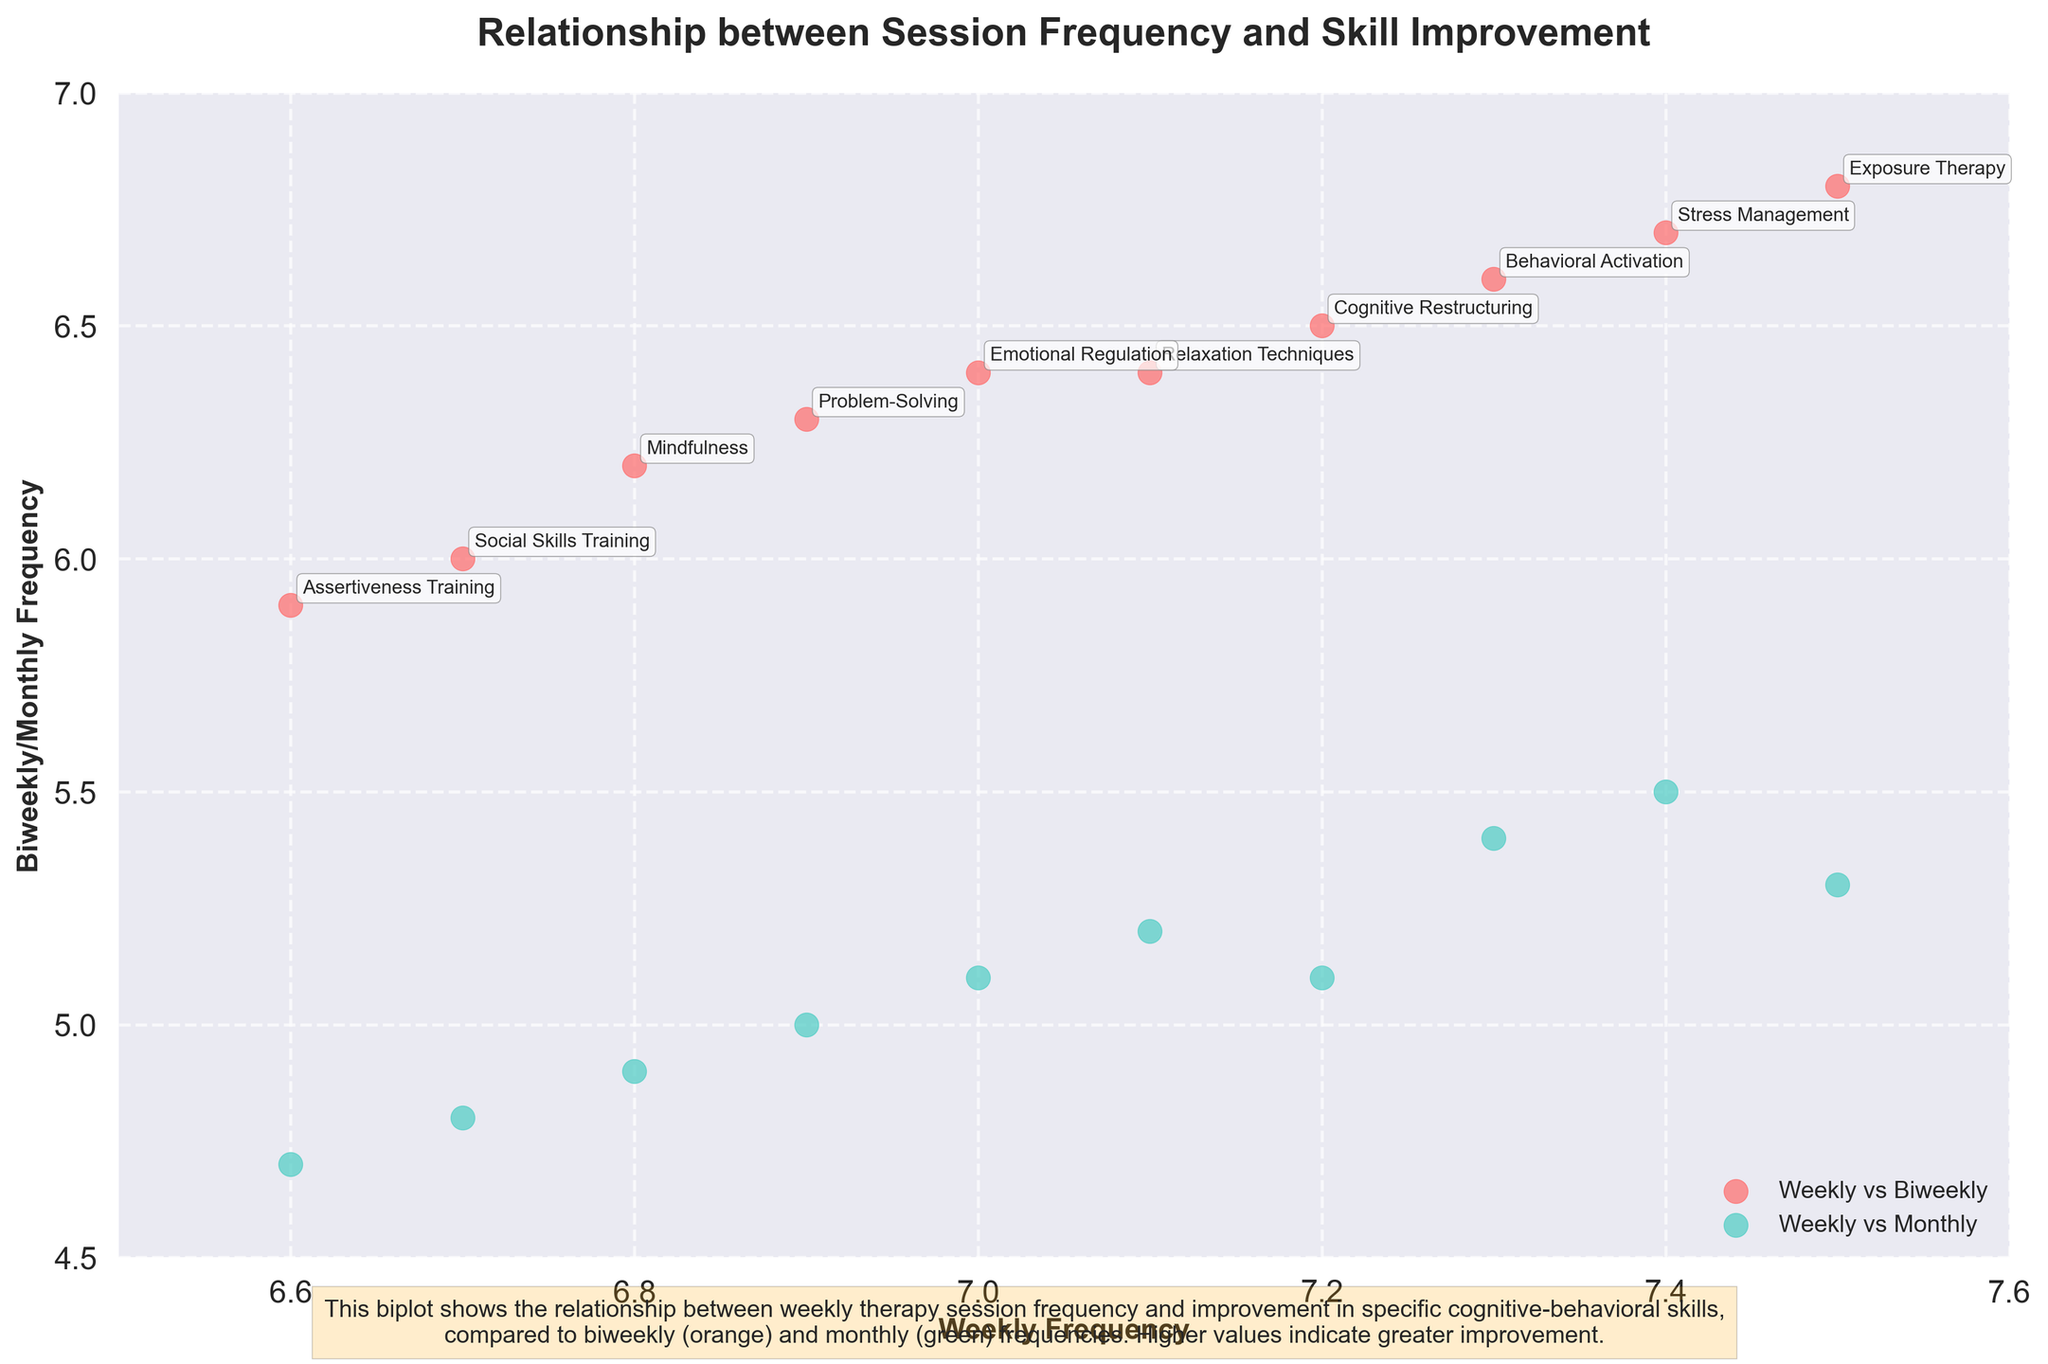What does the title of the plot indicate? The title "Relationship between Session Frequency and Skill Improvement" suggests that the plot examines how the frequency of therapy sessions relates to the improvement in specific cognitive-behavioral skills.
Answer: It indicates the relationship between session frequency and skill improvement How many skills are represented in the plot? Each annotated point in the plot represents a distinct skill, and there are 10 such annotations.
Answer: 10 skills What are the x and y axes labeled? The x-axis is labeled "Weekly Frequency," and the y-axis is labeled "Biweekly/Monthly Frequency."
Answer: "Weekly Frequency" and "Biweekly/Monthly Frequency" Which skills show the greatest improvement for weekly vs. biweekly frequencies? By identifying the points with the highest y-axis values in the "Weekly vs. Biweekly" scatter plot (red points), we see that "Exposure Therapy" and "Stress Management" have the greatest improvements.
Answer: "Exposure Therapy" and "Stress Management" How does the improvement in "Mindfulness" compare between weekly and monthly sessions? The point annotated with "Mindfulness" has a y-axis (monthly frequency) value of approximately 4.9 and an x-axis (weekly frequency) value of around 6.8, indicating that weekly sessions result in noticeably greater improvement.
Answer: Weekly sessions show greater improvement than monthly sessions Which frequency generally shows higher improvement: weekly or biweekly? Observing the general trend of the scatter plots, the red points (weekly vs. biweekly) are consistently positioned higher along the y-axis compared to the green points (weekly vs. monthly), indicating a trend where weekly frequencies show higher improvement over biweekly frequencies.
Answer: Weekly frequency What is the general trend between weekly and monthly session frequencies? By observing the positions of the green points (weekly vs. monthly), we can see that weekly frequencies, on the x-axis, generally result in higher improvement compared to monthly frequencies, on the y-axis.
Answer: Weekly frequencies show higher improvement than monthly frequencies What is the range of the weekly frequency values for the plotted skills? The x-axis values range from approximately 6.6 to 7.5.
Answer: 6.6 to 7.5 Which skill has the lowest improvement in both biweekly and monthly sessions? By examining the lower region of the y-axis for both scatter plots, "Assertiveness Training" has the lowest improvement in both biweekly and monthly sessions.
Answer: "Assertiveness Training" Are there any skills where biweekly sessions show almost as much improvement as weekly sessions? Looking at points where the red (weekly vs. biweekly) points are very close to the corresponding x-axis (weekly), "Problem-Solving" and "Emotional Regulation" show almost similar improvements in weekly and biweekly sessions.
Answer: "Problem-Solving" and "Emotional Regulation" 